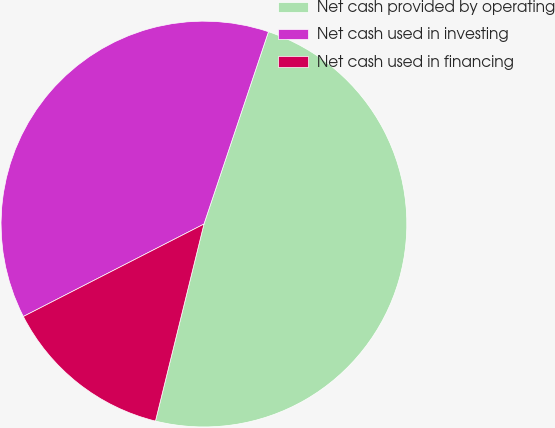<chart> <loc_0><loc_0><loc_500><loc_500><pie_chart><fcel>Net cash provided by operating<fcel>Net cash used in investing<fcel>Net cash used in financing<nl><fcel>48.69%<fcel>37.68%<fcel>13.63%<nl></chart> 